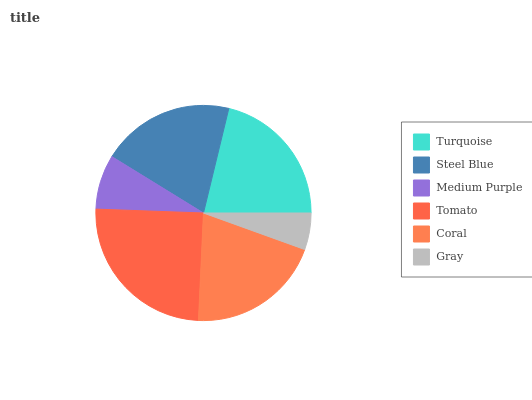Is Gray the minimum?
Answer yes or no. Yes. Is Tomato the maximum?
Answer yes or no. Yes. Is Steel Blue the minimum?
Answer yes or no. No. Is Steel Blue the maximum?
Answer yes or no. No. Is Turquoise greater than Steel Blue?
Answer yes or no. Yes. Is Steel Blue less than Turquoise?
Answer yes or no. Yes. Is Steel Blue greater than Turquoise?
Answer yes or no. No. Is Turquoise less than Steel Blue?
Answer yes or no. No. Is Coral the high median?
Answer yes or no. Yes. Is Steel Blue the low median?
Answer yes or no. Yes. Is Medium Purple the high median?
Answer yes or no. No. Is Coral the low median?
Answer yes or no. No. 